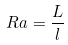<formula> <loc_0><loc_0><loc_500><loc_500>R a = \frac { L } { l }</formula> 